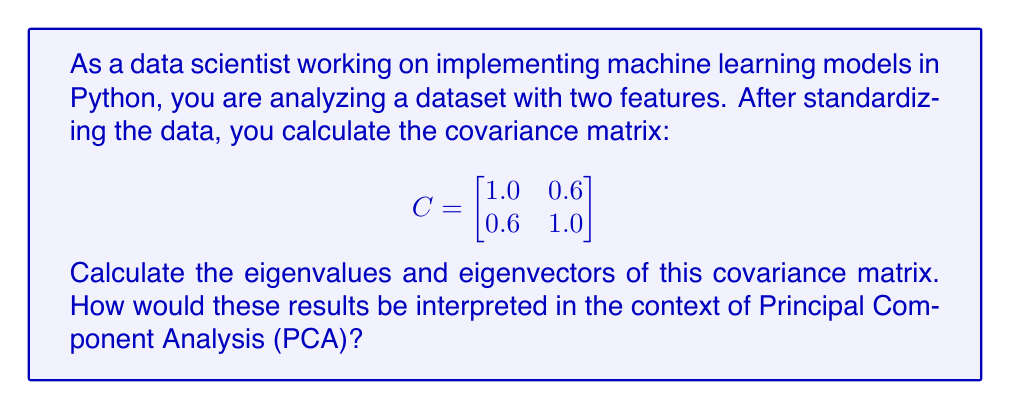Teach me how to tackle this problem. To find the eigenvalues and eigenvectors of the covariance matrix, we follow these steps:

1) The characteristic equation is given by $\det(C - \lambda I) = 0$, where $\lambda$ represents the eigenvalues.

2) Expanding this equation:

   $$\det\begin{pmatrix}
   1.0 - \lambda & 0.6 \\
   0.6 & 1.0 - \lambda
   \end{pmatrix} = 0$$

3) Calculating the determinant:

   $(1.0 - \lambda)(1.0 - \lambda) - (0.6)(0.6) = 0$
   $\lambda^2 - 2\lambda + 1 - 0.36 = 0$
   $\lambda^2 - 2\lambda + 0.64 = 0$

4) Solving this quadratic equation:

   $(\lambda - 1.6)(\lambda - 0.4) = 0$

   So, $\lambda_1 = 1.6$ and $\lambda_2 = 0.4$

5) For each eigenvalue, we find the corresponding eigenvector $v$ by solving $(C - \lambda I)v = 0$:

   For $\lambda_1 = 1.6$:
   $$\begin{pmatrix}
   -0.6 & 0.6 \\
   0.6 & -0.6
   \end{pmatrix}\begin{pmatrix}
   v_1 \\
   v_2
   \end{pmatrix} = \begin{pmatrix}
   0 \\
   0
   \end{pmatrix}$$

   This gives us $v_1 = v_2$. Normalizing, we get $v_1 = \frac{1}{\sqrt{2}}\begin{pmatrix}
   1 \\
   1
   \end{pmatrix}$

   For $\lambda_2 = 0.4$:
   $$\begin{pmatrix}
   0.6 & 0.6 \\
   0.6 & 0.6
   \end{pmatrix}\begin{pmatrix}
   v_1 \\
   v_2
   \end{pmatrix} = \begin{pmatrix}
   0 \\
   0
   \end{pmatrix}$$

   This gives us $v_1 = -v_2$. Normalizing, we get $v_2 = \frac{1}{\sqrt{2}}\begin{pmatrix}
   1 \\
   -1
   \end{pmatrix}$

Interpretation in PCA context:
- The eigenvalues represent the amount of variance explained by each principal component. $\lambda_1 = 1.6$ explains 80% of the variance, while $\lambda_2 = 0.4$ explains 20%.
- The eigenvectors represent the directions of these principal components in the original feature space.
- The first principal component (corresponding to $\lambda_1$) indicates that both features contribute equally and positively to the main direction of variance.
- The second principal component (corresponding to $\lambda_2$) represents the orthogonal direction, where the features have equal but opposite contributions.
Answer: Eigenvalues: $\lambda_1 = 1.6$, $\lambda_2 = 0.4$

Eigenvectors: 
$v_1 = \frac{1}{\sqrt{2}}\begin{pmatrix}
1 \\
1
\end{pmatrix}$, 
$v_2 = \frac{1}{\sqrt{2}}\begin{pmatrix}
1 \\
-1
\end{pmatrix}$

Interpretation: The first principal component explains 80% of the variance, with both features contributing equally. The second principal component explains the remaining 20% of the variance, with the features having equal but opposite contributions. 